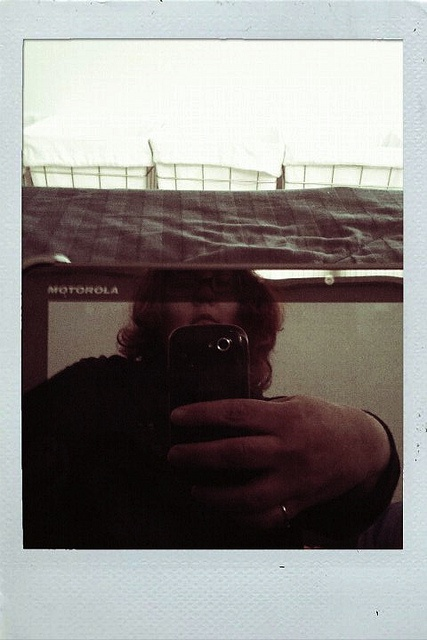Describe the objects in this image and their specific colors. I can see people in ivory, black, maroon, and gray tones, bed in ivory, maroon, gray, and black tones, and cell phone in ivory, black, maroon, gray, and darkgray tones in this image. 